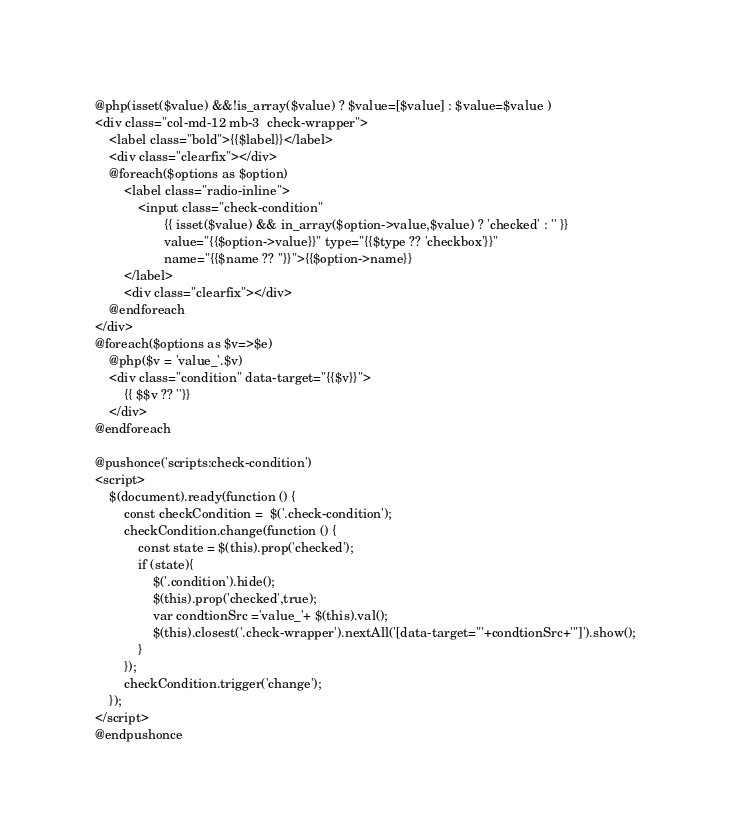Convert code to text. <code><loc_0><loc_0><loc_500><loc_500><_PHP_>@php(isset($value) &&!is_array($value) ? $value=[$value] : $value=$value )
<div class="col-md-12 mb-3  check-wrapper">
    <label class="bold">{{$label}}</label>
    <div class="clearfix"></div>
    @foreach($options as $option)
        <label class="radio-inline">
            <input class="check-condition"
                   {{ isset($value) && in_array($option->value,$value) ? 'checked' : '' }}
                   value="{{$option->value}}" type="{{$type ?? 'checkbox'}}"
                   name="{{$name ?? ''}}">{{$option->name}}
        </label>
        <div class="clearfix"></div>
    @endforeach
</div>
@foreach($options as $v=>$e)
    @php($v = 'value_'.$v)
    <div class="condition" data-target="{{$v}}">
        {{ $$v ?? ''}}
    </div>
@endforeach

@pushonce('scripts:check-condition')
<script>
    $(document).ready(function () {
        const checkCondition =  $('.check-condition');
        checkCondition.change(function () {
            const state = $(this).prop('checked');
            if (state){
                $('.condition').hide();
                $(this).prop('checked',true);
                var condtionSrc ='value_'+ $(this).val();
                $(this).closest('.check-wrapper').nextAll('[data-target="'+condtionSrc+'"]').show();
            }
        });
        checkCondition.trigger('change');
    });
</script>
@endpushonce</code> 